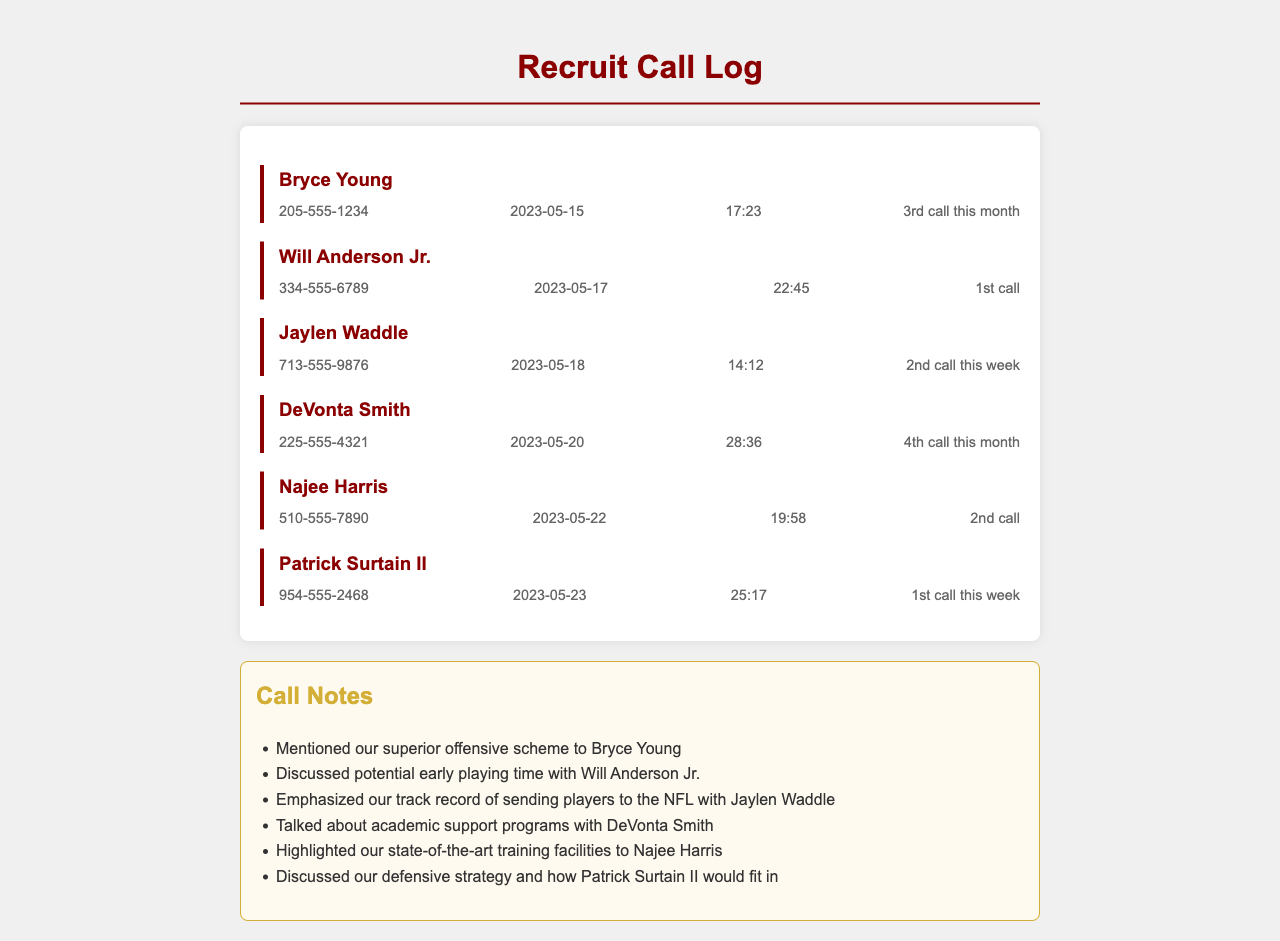What is the phone number for Bryce Young? The phone number is listed in the call log details for Bryce Young.
Answer: 205-555-1234 How many calls did we make to DeVonta Smith this month? The call log indicates this was the 4th call to DeVonta Smith in the month.
Answer: 4th What date did we first call Will Anderson Jr.? The first call date is provided in the log for Will Anderson Jr.
Answer: 2023-05-17 What was the duration of the call with Najee Harris? The duration of the call with Najee Harris is specified in the call log.
Answer: 19:58 Which player discussed academic support programs? The call notes indicate that the discussion about academic support was held with a specific player.
Answer: DeVonta Smith What is the total number of calls made to Bryce Young this month? The document states that this was the 3rd call made to Bryce Young this month.
Answer: 3rd What did we highlight to Najee Harris during the call? The call notes describe what aspect of the program we highlighted to Najee Harris.
Answer: state-of-the-art training facilities Who is the player associated with the phone number 954-555-2468? The call log shows which player is associated with this specific phone number.
Answer: Patrick Surtain II How many calls were made to Jaylen Waddle this week? The call log indicates the number of calls made to Jaylen Waddle in the week.
Answer: 2nd 